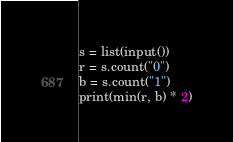<code> <loc_0><loc_0><loc_500><loc_500><_Python_>s = list(input())
r = s.count("0")
b = s.count("1")
print(min(r, b) * 2)</code> 